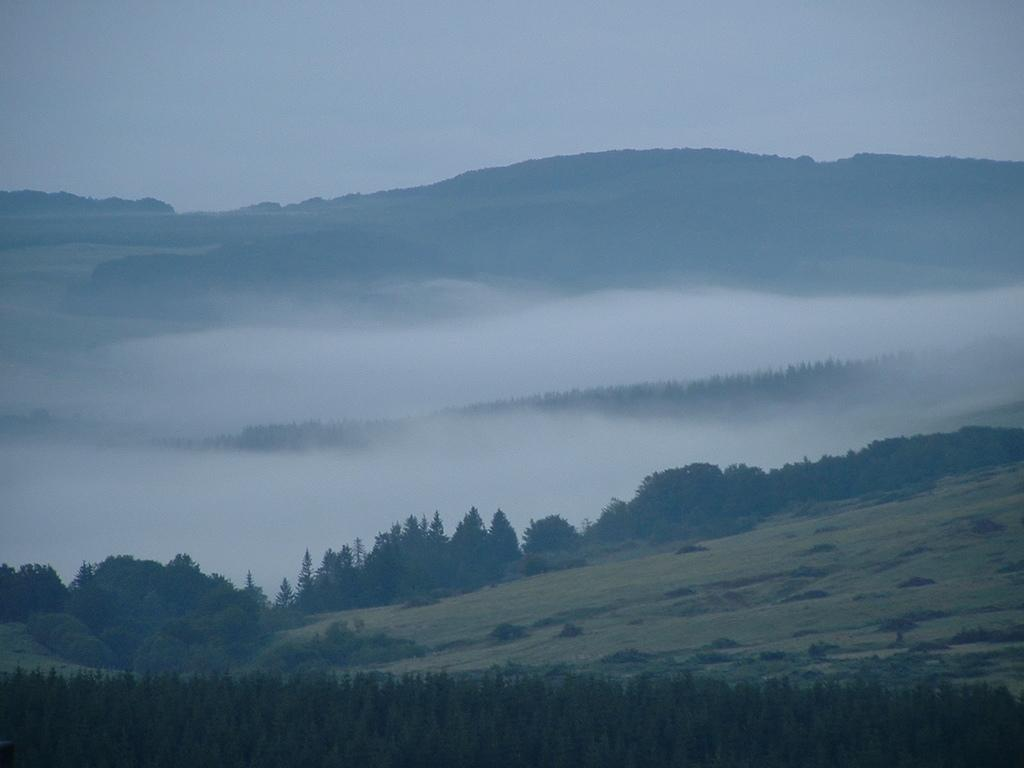What type of natural formation can be seen in the image? There are mountains in the image. What vegetation is present on the mountains? There are trees on the mountains. What is visible at the top of the image? The sky is visible at the top of the image. What type of vegetation is present at the bottom of the image? There is grass and plants at the bottom of the image. What type of guitar can be seen in the image? There is no guitar present in the image; it features mountains, trees, sky, grass, and plants. 